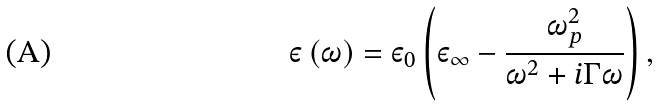Convert formula to latex. <formula><loc_0><loc_0><loc_500><loc_500>\varepsilon \left ( \omega \right ) = \varepsilon _ { 0 } \left ( \varepsilon _ { \infty } - \frac { \omega _ { p } ^ { 2 } } { \omega ^ { 2 } + i \Gamma \omega } \right ) ,</formula> 